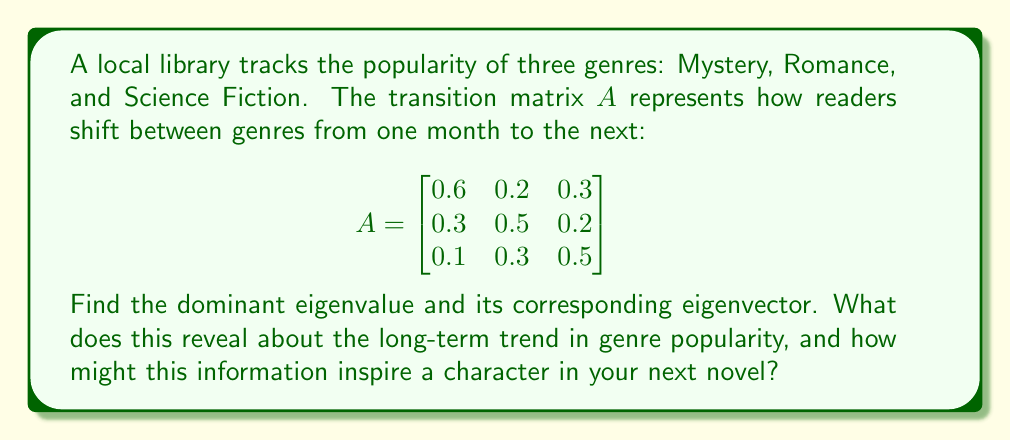Give your solution to this math problem. 1) First, we need to find the eigenvalues by solving the characteristic equation:
   $det(A - \lambda I) = 0$

2) Expanding this:
   $$(0.6-\lambda)(0.5-\lambda)(0.5-\lambda) - 0.3 \cdot 0.2 \cdot 0.1 - 0.3 \cdot 0.3 \cdot 0.2 - 0.1 \cdot 0.2 \cdot 0.5 = 0$$

3) This simplifies to:
   $$-\lambda^3 + 1.6\lambda^2 - 0.71\lambda + 0.088 = 0$$

4) Solving this equation (using a calculator or computer), we get:
   $\lambda_1 \approx 1$, $\lambda_2 \approx 0.3$, $\lambda_3 \approx 0.3$

5) The dominant eigenvalue is $\lambda_1 = 1$.

6) To find the corresponding eigenvector, we solve $(A - I)v = 0$:

   $$\begin{bmatrix}
   -0.4 & 0.2 & 0.3 \\
   0.3 & -0.5 & 0.2 \\
   0.1 & 0.3 & -0.5
   \end{bmatrix} \begin{bmatrix} v_1 \\ v_2 \\ v_3 \end{bmatrix} = \begin{bmatrix} 0 \\ 0 \\ 0 \end{bmatrix}$$

7) Solving this system, we get the eigenvector:
   $v \approx (0.4615, 0.3846, 0.1538)$

8) Normalizing this vector, we get:
   $v \approx (0.46, 0.38, 0.16)$

This eigenvector represents the long-term stable distribution of genre popularity. It suggests that in the long run, approximately 46% of readers will prefer Mystery, 38% will prefer Romance, and 16% will prefer Science Fiction.
Answer: Dominant eigenvalue: 1. Corresponding normalized eigenvector: (0.46, 0.38, 0.16). Long-term genre popularity: Mystery 46%, Romance 38%, Science Fiction 16%. 